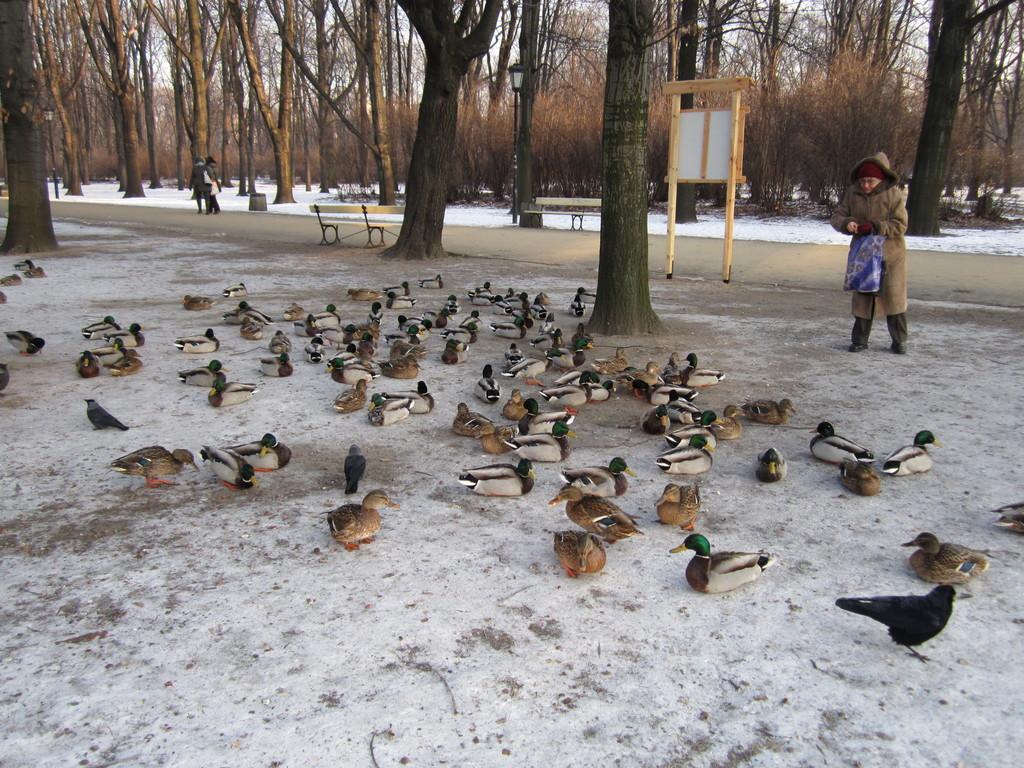In one or two sentences, can you explain what this image depicts? In this picture we can see birds on the ground, here we can see people, benches, poles with lights, wooden object and in the background we can see trees, snow, sky. 